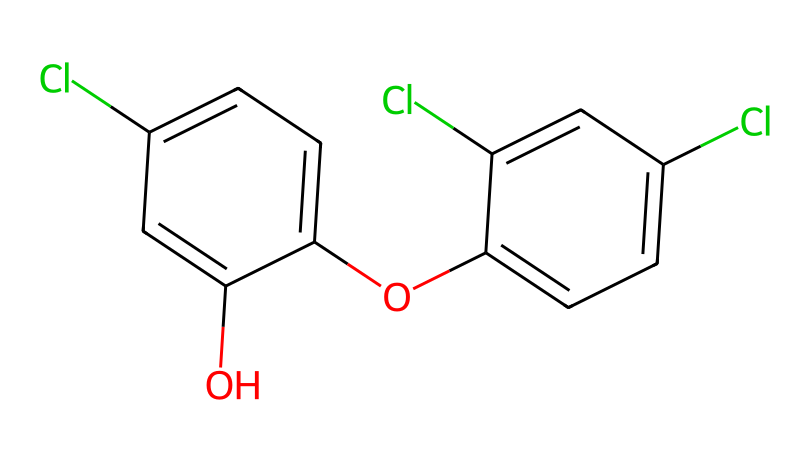How many chlorine atoms are present in this chemical? The chemical structure shows three positions where chlorine atoms are substituents on the aromatic rings. By counting these positions visually, we find a total of three chlorine atoms in the structure.
Answer: three What is the molecular formula based on the structure? The structure consists of multiple rings and substituents, and when analyzing, we see that there are several carbon, hydrogen, and chlorine atoms. The simplified molecular formula derived from the structure is C12H9Cl3O2.
Answer: C12H9Cl3O2 Which part of this chemical contributes to its antibacterial properties? The presence of hydroxyl (-OH) and chlorine (Cl) groups in the aromatic rings contributes to its antibacterial properties by disrupting bacterial cell membranes. Therefore, we can infer that these functional groups are key contributors to its effectiveness.
Answer: hydroxyl and chlorine groups What type of chemical structure is exhibited here? This structure is characteristic of polychlorinated phenols. It is specifically a diphenyl ether structure with multiple chlorine substitutions, indicating its classification as an antibacterial agent.
Answer: polychlorinated phenols How many total rings are present in this structure? Upon examining the structure, we can identify two distinct aromatic rings that are interconnected by an ether linkage. This leads us to conclude that there are two rings in total.
Answer: two What is the significance of the ether linkage in this chemical? The ether linkage allows for the combination of two aromatic rings while maintaining some flexibility in the molecular structure. This linkage is crucial for enhancing the overall biological activity, making it significant in its antibacterial function.
Answer: flexibility in molecular structure What type of functional groups are present in this compound? The chemical structure contains hydroxyl (-OH) and ether (R-O-R') functional groups due to the presence of aromatic rings and the oxygen atom in the linkage. These contribute to its reactivity and solubility properties.
Answer: hydroxyl and ether groups 